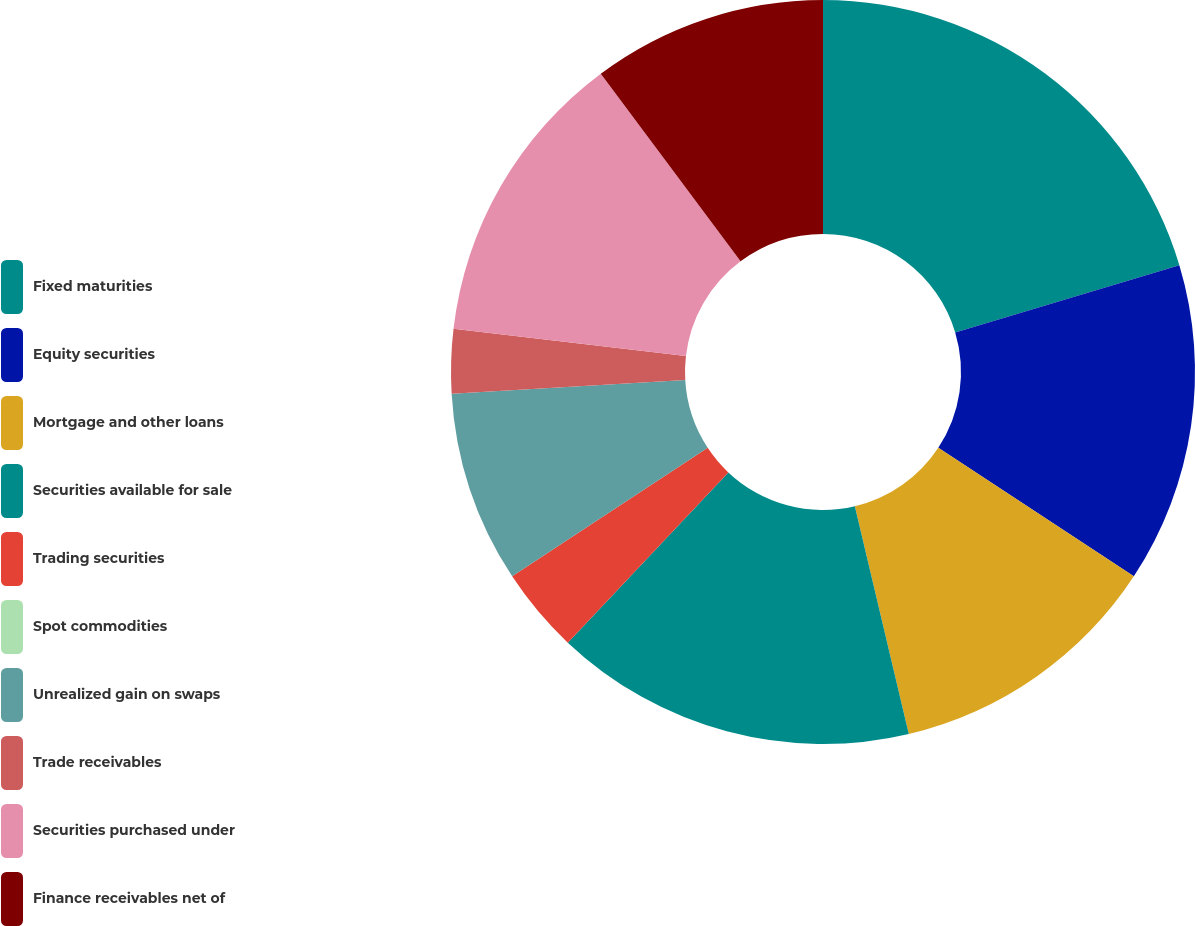Convert chart to OTSL. <chart><loc_0><loc_0><loc_500><loc_500><pie_chart><fcel>Fixed maturities<fcel>Equity securities<fcel>Mortgage and other loans<fcel>Securities available for sale<fcel>Trading securities<fcel>Spot commodities<fcel>Unrealized gain on swaps<fcel>Trade receivables<fcel>Securities purchased under<fcel>Finance receivables net of<nl><fcel>20.37%<fcel>13.89%<fcel>12.04%<fcel>15.74%<fcel>3.71%<fcel>0.0%<fcel>8.33%<fcel>2.78%<fcel>12.96%<fcel>10.19%<nl></chart> 